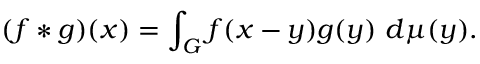<formula> <loc_0><loc_0><loc_500><loc_500>( f * g ) ( x ) = \int _ { G } f ( x - y ) g ( y ) \ d \mu ( y ) .</formula> 